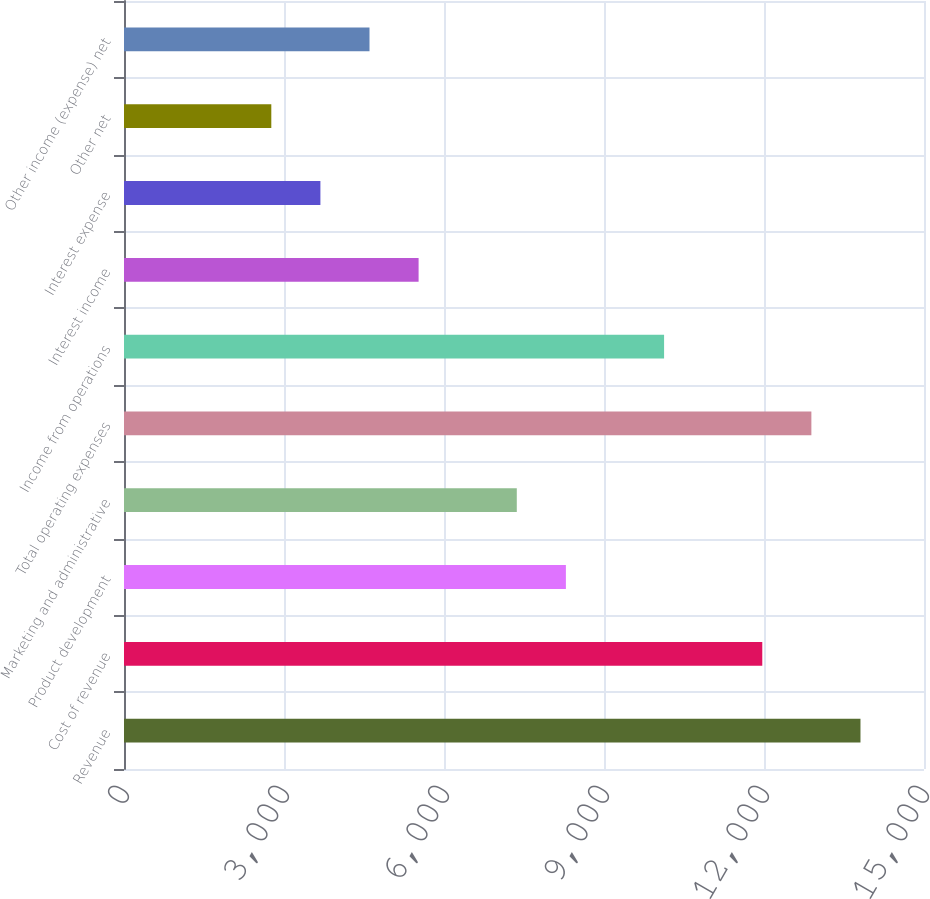Convert chart to OTSL. <chart><loc_0><loc_0><loc_500><loc_500><bar_chart><fcel>Revenue<fcel>Cost of revenue<fcel>Product development<fcel>Marketing and administrative<fcel>Total operating expenses<fcel>Income from operations<fcel>Interest income<fcel>Interest expense<fcel>Other net<fcel>Other income (expense) net<nl><fcel>13808.9<fcel>11967.7<fcel>8285.45<fcel>7364.88<fcel>12888.3<fcel>10126.6<fcel>5523.74<fcel>3682.6<fcel>2762.03<fcel>4603.17<nl></chart> 